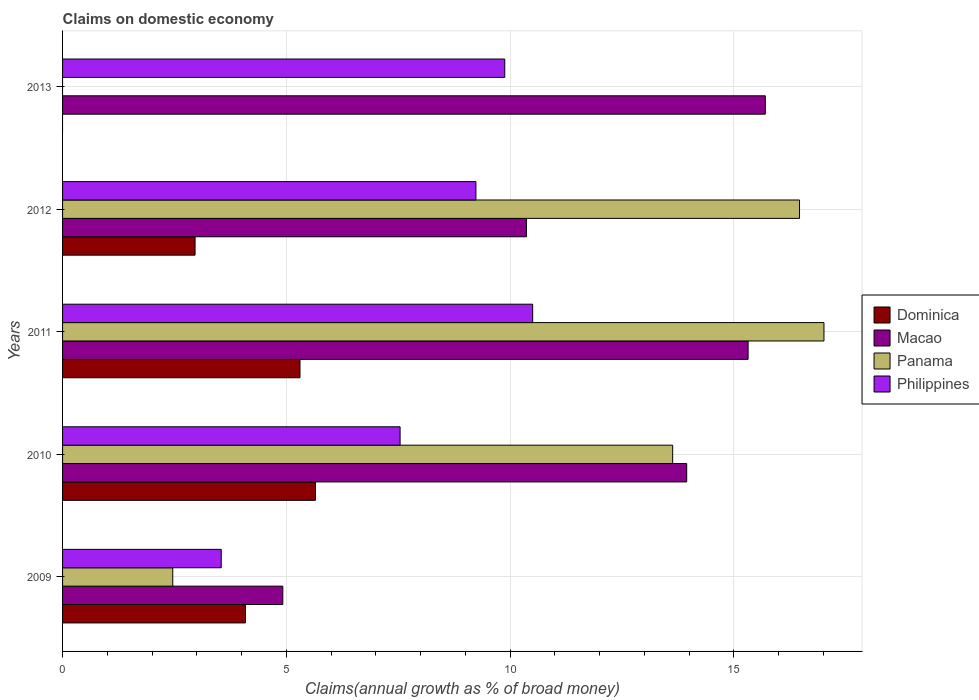Are the number of bars on each tick of the Y-axis equal?
Your response must be concise. No. How many bars are there on the 4th tick from the top?
Keep it short and to the point. 4. How many bars are there on the 2nd tick from the bottom?
Give a very brief answer. 4. What is the label of the 2nd group of bars from the top?
Your answer should be very brief. 2012. What is the percentage of broad money claimed on domestic economy in Philippines in 2013?
Offer a very short reply. 9.88. Across all years, what is the maximum percentage of broad money claimed on domestic economy in Panama?
Keep it short and to the point. 17.01. Across all years, what is the minimum percentage of broad money claimed on domestic economy in Macao?
Keep it short and to the point. 4.92. In which year was the percentage of broad money claimed on domestic economy in Macao maximum?
Keep it short and to the point. 2013. What is the total percentage of broad money claimed on domestic economy in Dominica in the graph?
Your answer should be compact. 18. What is the difference between the percentage of broad money claimed on domestic economy in Philippines in 2012 and that in 2013?
Keep it short and to the point. -0.64. What is the difference between the percentage of broad money claimed on domestic economy in Dominica in 2013 and the percentage of broad money claimed on domestic economy in Panama in 2012?
Provide a short and direct response. -16.47. What is the average percentage of broad money claimed on domestic economy in Dominica per year?
Keep it short and to the point. 3.6. In the year 2010, what is the difference between the percentage of broad money claimed on domestic economy in Panama and percentage of broad money claimed on domestic economy in Macao?
Your response must be concise. -0.31. What is the ratio of the percentage of broad money claimed on domestic economy in Philippines in 2009 to that in 2012?
Your answer should be very brief. 0.38. What is the difference between the highest and the second highest percentage of broad money claimed on domestic economy in Macao?
Offer a terse response. 0.38. What is the difference between the highest and the lowest percentage of broad money claimed on domestic economy in Philippines?
Offer a very short reply. 6.96. In how many years, is the percentage of broad money claimed on domestic economy in Philippines greater than the average percentage of broad money claimed on domestic economy in Philippines taken over all years?
Provide a short and direct response. 3. Is it the case that in every year, the sum of the percentage of broad money claimed on domestic economy in Dominica and percentage of broad money claimed on domestic economy in Macao is greater than the sum of percentage of broad money claimed on domestic economy in Panama and percentage of broad money claimed on domestic economy in Philippines?
Give a very brief answer. No. Are the values on the major ticks of X-axis written in scientific E-notation?
Provide a short and direct response. No. Does the graph contain any zero values?
Give a very brief answer. Yes. How many legend labels are there?
Give a very brief answer. 4. What is the title of the graph?
Ensure brevity in your answer.  Claims on domestic economy. What is the label or title of the X-axis?
Your answer should be very brief. Claims(annual growth as % of broad money). What is the label or title of the Y-axis?
Provide a short and direct response. Years. What is the Claims(annual growth as % of broad money) in Dominica in 2009?
Offer a very short reply. 4.09. What is the Claims(annual growth as % of broad money) of Macao in 2009?
Your answer should be very brief. 4.92. What is the Claims(annual growth as % of broad money) in Panama in 2009?
Your answer should be very brief. 2.46. What is the Claims(annual growth as % of broad money) of Philippines in 2009?
Keep it short and to the point. 3.55. What is the Claims(annual growth as % of broad money) of Dominica in 2010?
Provide a short and direct response. 5.65. What is the Claims(annual growth as % of broad money) of Macao in 2010?
Make the answer very short. 13.95. What is the Claims(annual growth as % of broad money) in Panama in 2010?
Give a very brief answer. 13.63. What is the Claims(annual growth as % of broad money) of Philippines in 2010?
Keep it short and to the point. 7.54. What is the Claims(annual growth as % of broad money) in Dominica in 2011?
Offer a terse response. 5.3. What is the Claims(annual growth as % of broad money) in Macao in 2011?
Offer a terse response. 15.32. What is the Claims(annual growth as % of broad money) in Panama in 2011?
Your answer should be compact. 17.01. What is the Claims(annual growth as % of broad money) of Philippines in 2011?
Your answer should be compact. 10.5. What is the Claims(annual growth as % of broad money) in Dominica in 2012?
Offer a very short reply. 2.96. What is the Claims(annual growth as % of broad money) of Macao in 2012?
Provide a succinct answer. 10.36. What is the Claims(annual growth as % of broad money) of Panama in 2012?
Provide a short and direct response. 16.47. What is the Claims(annual growth as % of broad money) in Philippines in 2012?
Give a very brief answer. 9.24. What is the Claims(annual growth as % of broad money) in Macao in 2013?
Offer a terse response. 15.7. What is the Claims(annual growth as % of broad money) in Philippines in 2013?
Provide a short and direct response. 9.88. Across all years, what is the maximum Claims(annual growth as % of broad money) in Dominica?
Your answer should be compact. 5.65. Across all years, what is the maximum Claims(annual growth as % of broad money) in Macao?
Offer a very short reply. 15.7. Across all years, what is the maximum Claims(annual growth as % of broad money) in Panama?
Your response must be concise. 17.01. Across all years, what is the maximum Claims(annual growth as % of broad money) of Philippines?
Give a very brief answer. 10.5. Across all years, what is the minimum Claims(annual growth as % of broad money) of Dominica?
Make the answer very short. 0. Across all years, what is the minimum Claims(annual growth as % of broad money) in Macao?
Your answer should be compact. 4.92. Across all years, what is the minimum Claims(annual growth as % of broad money) of Philippines?
Ensure brevity in your answer.  3.55. What is the total Claims(annual growth as % of broad money) of Dominica in the graph?
Your response must be concise. 18. What is the total Claims(annual growth as % of broad money) in Macao in the graph?
Your response must be concise. 60.25. What is the total Claims(annual growth as % of broad money) of Panama in the graph?
Offer a terse response. 49.57. What is the total Claims(annual growth as % of broad money) of Philippines in the graph?
Offer a very short reply. 40.71. What is the difference between the Claims(annual growth as % of broad money) of Dominica in 2009 and that in 2010?
Your answer should be very brief. -1.56. What is the difference between the Claims(annual growth as % of broad money) in Macao in 2009 and that in 2010?
Offer a terse response. -9.02. What is the difference between the Claims(annual growth as % of broad money) in Panama in 2009 and that in 2010?
Ensure brevity in your answer.  -11.17. What is the difference between the Claims(annual growth as % of broad money) in Philippines in 2009 and that in 2010?
Offer a terse response. -4. What is the difference between the Claims(annual growth as % of broad money) of Dominica in 2009 and that in 2011?
Make the answer very short. -1.22. What is the difference between the Claims(annual growth as % of broad money) in Macao in 2009 and that in 2011?
Your answer should be very brief. -10.4. What is the difference between the Claims(annual growth as % of broad money) in Panama in 2009 and that in 2011?
Give a very brief answer. -14.55. What is the difference between the Claims(annual growth as % of broad money) in Philippines in 2009 and that in 2011?
Ensure brevity in your answer.  -6.96. What is the difference between the Claims(annual growth as % of broad money) in Dominica in 2009 and that in 2012?
Your answer should be very brief. 1.13. What is the difference between the Claims(annual growth as % of broad money) of Macao in 2009 and that in 2012?
Offer a very short reply. -5.44. What is the difference between the Claims(annual growth as % of broad money) in Panama in 2009 and that in 2012?
Your answer should be very brief. -14. What is the difference between the Claims(annual growth as % of broad money) of Philippines in 2009 and that in 2012?
Provide a succinct answer. -5.69. What is the difference between the Claims(annual growth as % of broad money) in Macao in 2009 and that in 2013?
Your answer should be very brief. -10.78. What is the difference between the Claims(annual growth as % of broad money) of Philippines in 2009 and that in 2013?
Ensure brevity in your answer.  -6.34. What is the difference between the Claims(annual growth as % of broad money) of Dominica in 2010 and that in 2011?
Your answer should be very brief. 0.35. What is the difference between the Claims(annual growth as % of broad money) of Macao in 2010 and that in 2011?
Keep it short and to the point. -1.37. What is the difference between the Claims(annual growth as % of broad money) of Panama in 2010 and that in 2011?
Ensure brevity in your answer.  -3.38. What is the difference between the Claims(annual growth as % of broad money) of Philippines in 2010 and that in 2011?
Give a very brief answer. -2.96. What is the difference between the Claims(annual growth as % of broad money) of Dominica in 2010 and that in 2012?
Offer a terse response. 2.69. What is the difference between the Claims(annual growth as % of broad money) in Macao in 2010 and that in 2012?
Keep it short and to the point. 3.58. What is the difference between the Claims(annual growth as % of broad money) in Panama in 2010 and that in 2012?
Your response must be concise. -2.83. What is the difference between the Claims(annual growth as % of broad money) of Philippines in 2010 and that in 2012?
Ensure brevity in your answer.  -1.69. What is the difference between the Claims(annual growth as % of broad money) of Macao in 2010 and that in 2013?
Your answer should be compact. -1.76. What is the difference between the Claims(annual growth as % of broad money) in Philippines in 2010 and that in 2013?
Ensure brevity in your answer.  -2.34. What is the difference between the Claims(annual growth as % of broad money) in Dominica in 2011 and that in 2012?
Make the answer very short. 2.34. What is the difference between the Claims(annual growth as % of broad money) of Macao in 2011 and that in 2012?
Provide a succinct answer. 4.95. What is the difference between the Claims(annual growth as % of broad money) of Panama in 2011 and that in 2012?
Offer a terse response. 0.55. What is the difference between the Claims(annual growth as % of broad money) in Philippines in 2011 and that in 2012?
Keep it short and to the point. 1.27. What is the difference between the Claims(annual growth as % of broad money) in Macao in 2011 and that in 2013?
Offer a very short reply. -0.38. What is the difference between the Claims(annual growth as % of broad money) in Philippines in 2011 and that in 2013?
Ensure brevity in your answer.  0.62. What is the difference between the Claims(annual growth as % of broad money) in Macao in 2012 and that in 2013?
Offer a very short reply. -5.34. What is the difference between the Claims(annual growth as % of broad money) of Philippines in 2012 and that in 2013?
Give a very brief answer. -0.64. What is the difference between the Claims(annual growth as % of broad money) in Dominica in 2009 and the Claims(annual growth as % of broad money) in Macao in 2010?
Your answer should be compact. -9.86. What is the difference between the Claims(annual growth as % of broad money) of Dominica in 2009 and the Claims(annual growth as % of broad money) of Panama in 2010?
Your answer should be compact. -9.55. What is the difference between the Claims(annual growth as % of broad money) in Dominica in 2009 and the Claims(annual growth as % of broad money) in Philippines in 2010?
Your answer should be very brief. -3.46. What is the difference between the Claims(annual growth as % of broad money) of Macao in 2009 and the Claims(annual growth as % of broad money) of Panama in 2010?
Offer a terse response. -8.71. What is the difference between the Claims(annual growth as % of broad money) of Macao in 2009 and the Claims(annual growth as % of broad money) of Philippines in 2010?
Make the answer very short. -2.62. What is the difference between the Claims(annual growth as % of broad money) of Panama in 2009 and the Claims(annual growth as % of broad money) of Philippines in 2010?
Ensure brevity in your answer.  -5.08. What is the difference between the Claims(annual growth as % of broad money) in Dominica in 2009 and the Claims(annual growth as % of broad money) in Macao in 2011?
Offer a very short reply. -11.23. What is the difference between the Claims(annual growth as % of broad money) of Dominica in 2009 and the Claims(annual growth as % of broad money) of Panama in 2011?
Make the answer very short. -12.93. What is the difference between the Claims(annual growth as % of broad money) of Dominica in 2009 and the Claims(annual growth as % of broad money) of Philippines in 2011?
Offer a terse response. -6.42. What is the difference between the Claims(annual growth as % of broad money) in Macao in 2009 and the Claims(annual growth as % of broad money) in Panama in 2011?
Ensure brevity in your answer.  -12.09. What is the difference between the Claims(annual growth as % of broad money) of Macao in 2009 and the Claims(annual growth as % of broad money) of Philippines in 2011?
Offer a very short reply. -5.58. What is the difference between the Claims(annual growth as % of broad money) of Panama in 2009 and the Claims(annual growth as % of broad money) of Philippines in 2011?
Your response must be concise. -8.04. What is the difference between the Claims(annual growth as % of broad money) in Dominica in 2009 and the Claims(annual growth as % of broad money) in Macao in 2012?
Give a very brief answer. -6.28. What is the difference between the Claims(annual growth as % of broad money) of Dominica in 2009 and the Claims(annual growth as % of broad money) of Panama in 2012?
Ensure brevity in your answer.  -12.38. What is the difference between the Claims(annual growth as % of broad money) in Dominica in 2009 and the Claims(annual growth as % of broad money) in Philippines in 2012?
Ensure brevity in your answer.  -5.15. What is the difference between the Claims(annual growth as % of broad money) in Macao in 2009 and the Claims(annual growth as % of broad money) in Panama in 2012?
Your answer should be compact. -11.55. What is the difference between the Claims(annual growth as % of broad money) in Macao in 2009 and the Claims(annual growth as % of broad money) in Philippines in 2012?
Your answer should be compact. -4.32. What is the difference between the Claims(annual growth as % of broad money) in Panama in 2009 and the Claims(annual growth as % of broad money) in Philippines in 2012?
Keep it short and to the point. -6.77. What is the difference between the Claims(annual growth as % of broad money) in Dominica in 2009 and the Claims(annual growth as % of broad money) in Macao in 2013?
Ensure brevity in your answer.  -11.62. What is the difference between the Claims(annual growth as % of broad money) in Dominica in 2009 and the Claims(annual growth as % of broad money) in Philippines in 2013?
Provide a succinct answer. -5.79. What is the difference between the Claims(annual growth as % of broad money) in Macao in 2009 and the Claims(annual growth as % of broad money) in Philippines in 2013?
Ensure brevity in your answer.  -4.96. What is the difference between the Claims(annual growth as % of broad money) of Panama in 2009 and the Claims(annual growth as % of broad money) of Philippines in 2013?
Keep it short and to the point. -7.42. What is the difference between the Claims(annual growth as % of broad money) in Dominica in 2010 and the Claims(annual growth as % of broad money) in Macao in 2011?
Give a very brief answer. -9.67. What is the difference between the Claims(annual growth as % of broad money) of Dominica in 2010 and the Claims(annual growth as % of broad money) of Panama in 2011?
Your response must be concise. -11.36. What is the difference between the Claims(annual growth as % of broad money) in Dominica in 2010 and the Claims(annual growth as % of broad money) in Philippines in 2011?
Offer a terse response. -4.85. What is the difference between the Claims(annual growth as % of broad money) of Macao in 2010 and the Claims(annual growth as % of broad money) of Panama in 2011?
Make the answer very short. -3.07. What is the difference between the Claims(annual growth as % of broad money) in Macao in 2010 and the Claims(annual growth as % of broad money) in Philippines in 2011?
Provide a succinct answer. 3.44. What is the difference between the Claims(annual growth as % of broad money) in Panama in 2010 and the Claims(annual growth as % of broad money) in Philippines in 2011?
Provide a short and direct response. 3.13. What is the difference between the Claims(annual growth as % of broad money) in Dominica in 2010 and the Claims(annual growth as % of broad money) in Macao in 2012?
Ensure brevity in your answer.  -4.71. What is the difference between the Claims(annual growth as % of broad money) of Dominica in 2010 and the Claims(annual growth as % of broad money) of Panama in 2012?
Offer a terse response. -10.82. What is the difference between the Claims(annual growth as % of broad money) of Dominica in 2010 and the Claims(annual growth as % of broad money) of Philippines in 2012?
Keep it short and to the point. -3.59. What is the difference between the Claims(annual growth as % of broad money) in Macao in 2010 and the Claims(annual growth as % of broad money) in Panama in 2012?
Your answer should be compact. -2.52. What is the difference between the Claims(annual growth as % of broad money) of Macao in 2010 and the Claims(annual growth as % of broad money) of Philippines in 2012?
Your answer should be very brief. 4.71. What is the difference between the Claims(annual growth as % of broad money) of Panama in 2010 and the Claims(annual growth as % of broad money) of Philippines in 2012?
Ensure brevity in your answer.  4.4. What is the difference between the Claims(annual growth as % of broad money) of Dominica in 2010 and the Claims(annual growth as % of broad money) of Macao in 2013?
Provide a short and direct response. -10.05. What is the difference between the Claims(annual growth as % of broad money) in Dominica in 2010 and the Claims(annual growth as % of broad money) in Philippines in 2013?
Offer a terse response. -4.23. What is the difference between the Claims(annual growth as % of broad money) in Macao in 2010 and the Claims(annual growth as % of broad money) in Philippines in 2013?
Offer a terse response. 4.07. What is the difference between the Claims(annual growth as % of broad money) in Panama in 2010 and the Claims(annual growth as % of broad money) in Philippines in 2013?
Ensure brevity in your answer.  3.75. What is the difference between the Claims(annual growth as % of broad money) of Dominica in 2011 and the Claims(annual growth as % of broad money) of Macao in 2012?
Give a very brief answer. -5.06. What is the difference between the Claims(annual growth as % of broad money) of Dominica in 2011 and the Claims(annual growth as % of broad money) of Panama in 2012?
Offer a very short reply. -11.16. What is the difference between the Claims(annual growth as % of broad money) in Dominica in 2011 and the Claims(annual growth as % of broad money) in Philippines in 2012?
Provide a succinct answer. -3.93. What is the difference between the Claims(annual growth as % of broad money) of Macao in 2011 and the Claims(annual growth as % of broad money) of Panama in 2012?
Offer a terse response. -1.15. What is the difference between the Claims(annual growth as % of broad money) of Macao in 2011 and the Claims(annual growth as % of broad money) of Philippines in 2012?
Give a very brief answer. 6.08. What is the difference between the Claims(annual growth as % of broad money) in Panama in 2011 and the Claims(annual growth as % of broad money) in Philippines in 2012?
Provide a succinct answer. 7.78. What is the difference between the Claims(annual growth as % of broad money) in Dominica in 2011 and the Claims(annual growth as % of broad money) in Macao in 2013?
Offer a very short reply. -10.4. What is the difference between the Claims(annual growth as % of broad money) in Dominica in 2011 and the Claims(annual growth as % of broad money) in Philippines in 2013?
Your response must be concise. -4.58. What is the difference between the Claims(annual growth as % of broad money) in Macao in 2011 and the Claims(annual growth as % of broad money) in Philippines in 2013?
Your response must be concise. 5.44. What is the difference between the Claims(annual growth as % of broad money) of Panama in 2011 and the Claims(annual growth as % of broad money) of Philippines in 2013?
Provide a succinct answer. 7.13. What is the difference between the Claims(annual growth as % of broad money) in Dominica in 2012 and the Claims(annual growth as % of broad money) in Macao in 2013?
Ensure brevity in your answer.  -12.74. What is the difference between the Claims(annual growth as % of broad money) in Dominica in 2012 and the Claims(annual growth as % of broad money) in Philippines in 2013?
Give a very brief answer. -6.92. What is the difference between the Claims(annual growth as % of broad money) of Macao in 2012 and the Claims(annual growth as % of broad money) of Philippines in 2013?
Give a very brief answer. 0.48. What is the difference between the Claims(annual growth as % of broad money) of Panama in 2012 and the Claims(annual growth as % of broad money) of Philippines in 2013?
Provide a short and direct response. 6.59. What is the average Claims(annual growth as % of broad money) in Dominica per year?
Offer a terse response. 3.6. What is the average Claims(annual growth as % of broad money) of Macao per year?
Keep it short and to the point. 12.05. What is the average Claims(annual growth as % of broad money) in Panama per year?
Your answer should be compact. 9.91. What is the average Claims(annual growth as % of broad money) in Philippines per year?
Your answer should be very brief. 8.14. In the year 2009, what is the difference between the Claims(annual growth as % of broad money) of Dominica and Claims(annual growth as % of broad money) of Macao?
Keep it short and to the point. -0.83. In the year 2009, what is the difference between the Claims(annual growth as % of broad money) of Dominica and Claims(annual growth as % of broad money) of Panama?
Offer a terse response. 1.62. In the year 2009, what is the difference between the Claims(annual growth as % of broad money) in Dominica and Claims(annual growth as % of broad money) in Philippines?
Offer a terse response. 0.54. In the year 2009, what is the difference between the Claims(annual growth as % of broad money) of Macao and Claims(annual growth as % of broad money) of Panama?
Offer a very short reply. 2.46. In the year 2009, what is the difference between the Claims(annual growth as % of broad money) of Macao and Claims(annual growth as % of broad money) of Philippines?
Offer a very short reply. 1.38. In the year 2009, what is the difference between the Claims(annual growth as % of broad money) in Panama and Claims(annual growth as % of broad money) in Philippines?
Offer a very short reply. -1.08. In the year 2010, what is the difference between the Claims(annual growth as % of broad money) in Dominica and Claims(annual growth as % of broad money) in Macao?
Keep it short and to the point. -8.3. In the year 2010, what is the difference between the Claims(annual growth as % of broad money) in Dominica and Claims(annual growth as % of broad money) in Panama?
Your answer should be compact. -7.98. In the year 2010, what is the difference between the Claims(annual growth as % of broad money) in Dominica and Claims(annual growth as % of broad money) in Philippines?
Your answer should be very brief. -1.89. In the year 2010, what is the difference between the Claims(annual growth as % of broad money) of Macao and Claims(annual growth as % of broad money) of Panama?
Your answer should be compact. 0.31. In the year 2010, what is the difference between the Claims(annual growth as % of broad money) in Macao and Claims(annual growth as % of broad money) in Philippines?
Your answer should be very brief. 6.4. In the year 2010, what is the difference between the Claims(annual growth as % of broad money) in Panama and Claims(annual growth as % of broad money) in Philippines?
Offer a very short reply. 6.09. In the year 2011, what is the difference between the Claims(annual growth as % of broad money) in Dominica and Claims(annual growth as % of broad money) in Macao?
Your answer should be compact. -10.01. In the year 2011, what is the difference between the Claims(annual growth as % of broad money) of Dominica and Claims(annual growth as % of broad money) of Panama?
Your answer should be very brief. -11.71. In the year 2011, what is the difference between the Claims(annual growth as % of broad money) in Dominica and Claims(annual growth as % of broad money) in Philippines?
Keep it short and to the point. -5.2. In the year 2011, what is the difference between the Claims(annual growth as % of broad money) in Macao and Claims(annual growth as % of broad money) in Panama?
Provide a succinct answer. -1.7. In the year 2011, what is the difference between the Claims(annual growth as % of broad money) of Macao and Claims(annual growth as % of broad money) of Philippines?
Offer a terse response. 4.81. In the year 2011, what is the difference between the Claims(annual growth as % of broad money) of Panama and Claims(annual growth as % of broad money) of Philippines?
Offer a terse response. 6.51. In the year 2012, what is the difference between the Claims(annual growth as % of broad money) of Dominica and Claims(annual growth as % of broad money) of Macao?
Offer a terse response. -7.4. In the year 2012, what is the difference between the Claims(annual growth as % of broad money) in Dominica and Claims(annual growth as % of broad money) in Panama?
Your answer should be very brief. -13.51. In the year 2012, what is the difference between the Claims(annual growth as % of broad money) in Dominica and Claims(annual growth as % of broad money) in Philippines?
Your answer should be very brief. -6.28. In the year 2012, what is the difference between the Claims(annual growth as % of broad money) in Macao and Claims(annual growth as % of broad money) in Panama?
Your response must be concise. -6.1. In the year 2012, what is the difference between the Claims(annual growth as % of broad money) in Macao and Claims(annual growth as % of broad money) in Philippines?
Your answer should be very brief. 1.13. In the year 2012, what is the difference between the Claims(annual growth as % of broad money) in Panama and Claims(annual growth as % of broad money) in Philippines?
Your response must be concise. 7.23. In the year 2013, what is the difference between the Claims(annual growth as % of broad money) of Macao and Claims(annual growth as % of broad money) of Philippines?
Offer a terse response. 5.82. What is the ratio of the Claims(annual growth as % of broad money) of Dominica in 2009 to that in 2010?
Give a very brief answer. 0.72. What is the ratio of the Claims(annual growth as % of broad money) of Macao in 2009 to that in 2010?
Provide a short and direct response. 0.35. What is the ratio of the Claims(annual growth as % of broad money) of Panama in 2009 to that in 2010?
Provide a succinct answer. 0.18. What is the ratio of the Claims(annual growth as % of broad money) of Philippines in 2009 to that in 2010?
Keep it short and to the point. 0.47. What is the ratio of the Claims(annual growth as % of broad money) in Dominica in 2009 to that in 2011?
Give a very brief answer. 0.77. What is the ratio of the Claims(annual growth as % of broad money) of Macao in 2009 to that in 2011?
Keep it short and to the point. 0.32. What is the ratio of the Claims(annual growth as % of broad money) of Panama in 2009 to that in 2011?
Your response must be concise. 0.14. What is the ratio of the Claims(annual growth as % of broad money) of Philippines in 2009 to that in 2011?
Your answer should be very brief. 0.34. What is the ratio of the Claims(annual growth as % of broad money) in Dominica in 2009 to that in 2012?
Your response must be concise. 1.38. What is the ratio of the Claims(annual growth as % of broad money) of Macao in 2009 to that in 2012?
Offer a very short reply. 0.47. What is the ratio of the Claims(annual growth as % of broad money) of Panama in 2009 to that in 2012?
Provide a short and direct response. 0.15. What is the ratio of the Claims(annual growth as % of broad money) of Philippines in 2009 to that in 2012?
Give a very brief answer. 0.38. What is the ratio of the Claims(annual growth as % of broad money) in Macao in 2009 to that in 2013?
Provide a succinct answer. 0.31. What is the ratio of the Claims(annual growth as % of broad money) in Philippines in 2009 to that in 2013?
Ensure brevity in your answer.  0.36. What is the ratio of the Claims(annual growth as % of broad money) in Dominica in 2010 to that in 2011?
Offer a terse response. 1.07. What is the ratio of the Claims(annual growth as % of broad money) of Macao in 2010 to that in 2011?
Your response must be concise. 0.91. What is the ratio of the Claims(annual growth as % of broad money) in Panama in 2010 to that in 2011?
Keep it short and to the point. 0.8. What is the ratio of the Claims(annual growth as % of broad money) of Philippines in 2010 to that in 2011?
Offer a very short reply. 0.72. What is the ratio of the Claims(annual growth as % of broad money) of Dominica in 2010 to that in 2012?
Your answer should be very brief. 1.91. What is the ratio of the Claims(annual growth as % of broad money) in Macao in 2010 to that in 2012?
Provide a short and direct response. 1.35. What is the ratio of the Claims(annual growth as % of broad money) of Panama in 2010 to that in 2012?
Your response must be concise. 0.83. What is the ratio of the Claims(annual growth as % of broad money) of Philippines in 2010 to that in 2012?
Keep it short and to the point. 0.82. What is the ratio of the Claims(annual growth as % of broad money) of Macao in 2010 to that in 2013?
Make the answer very short. 0.89. What is the ratio of the Claims(annual growth as % of broad money) of Philippines in 2010 to that in 2013?
Offer a terse response. 0.76. What is the ratio of the Claims(annual growth as % of broad money) of Dominica in 2011 to that in 2012?
Your answer should be very brief. 1.79. What is the ratio of the Claims(annual growth as % of broad money) of Macao in 2011 to that in 2012?
Your response must be concise. 1.48. What is the ratio of the Claims(annual growth as % of broad money) in Panama in 2011 to that in 2012?
Offer a terse response. 1.03. What is the ratio of the Claims(annual growth as % of broad money) in Philippines in 2011 to that in 2012?
Provide a succinct answer. 1.14. What is the ratio of the Claims(annual growth as % of broad money) of Macao in 2011 to that in 2013?
Offer a terse response. 0.98. What is the ratio of the Claims(annual growth as % of broad money) in Philippines in 2011 to that in 2013?
Your response must be concise. 1.06. What is the ratio of the Claims(annual growth as % of broad money) of Macao in 2012 to that in 2013?
Ensure brevity in your answer.  0.66. What is the ratio of the Claims(annual growth as % of broad money) in Philippines in 2012 to that in 2013?
Provide a succinct answer. 0.93. What is the difference between the highest and the second highest Claims(annual growth as % of broad money) of Dominica?
Give a very brief answer. 0.35. What is the difference between the highest and the second highest Claims(annual growth as % of broad money) of Macao?
Your answer should be very brief. 0.38. What is the difference between the highest and the second highest Claims(annual growth as % of broad money) in Panama?
Your answer should be compact. 0.55. What is the difference between the highest and the second highest Claims(annual growth as % of broad money) in Philippines?
Your response must be concise. 0.62. What is the difference between the highest and the lowest Claims(annual growth as % of broad money) of Dominica?
Offer a terse response. 5.65. What is the difference between the highest and the lowest Claims(annual growth as % of broad money) of Macao?
Keep it short and to the point. 10.78. What is the difference between the highest and the lowest Claims(annual growth as % of broad money) of Panama?
Your answer should be compact. 17.01. What is the difference between the highest and the lowest Claims(annual growth as % of broad money) in Philippines?
Provide a short and direct response. 6.96. 